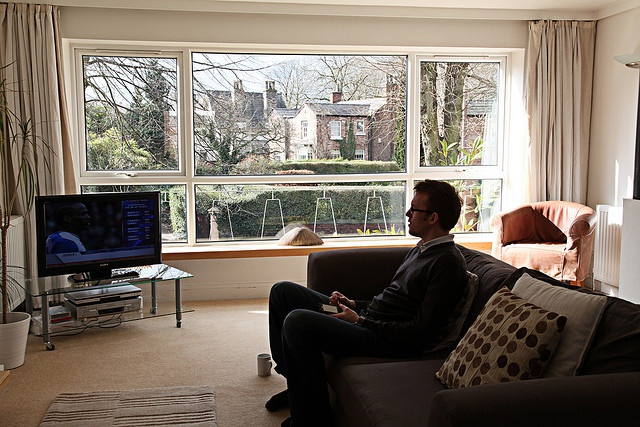Describe the objects in this image and their specific colors. I can see couch in gray, black, and maroon tones, people in gray, black, and maroon tones, couch in gray, black, and maroon tones, tv in gray, black, navy, and darkblue tones, and chair in gray, white, maroon, black, and tan tones in this image. 